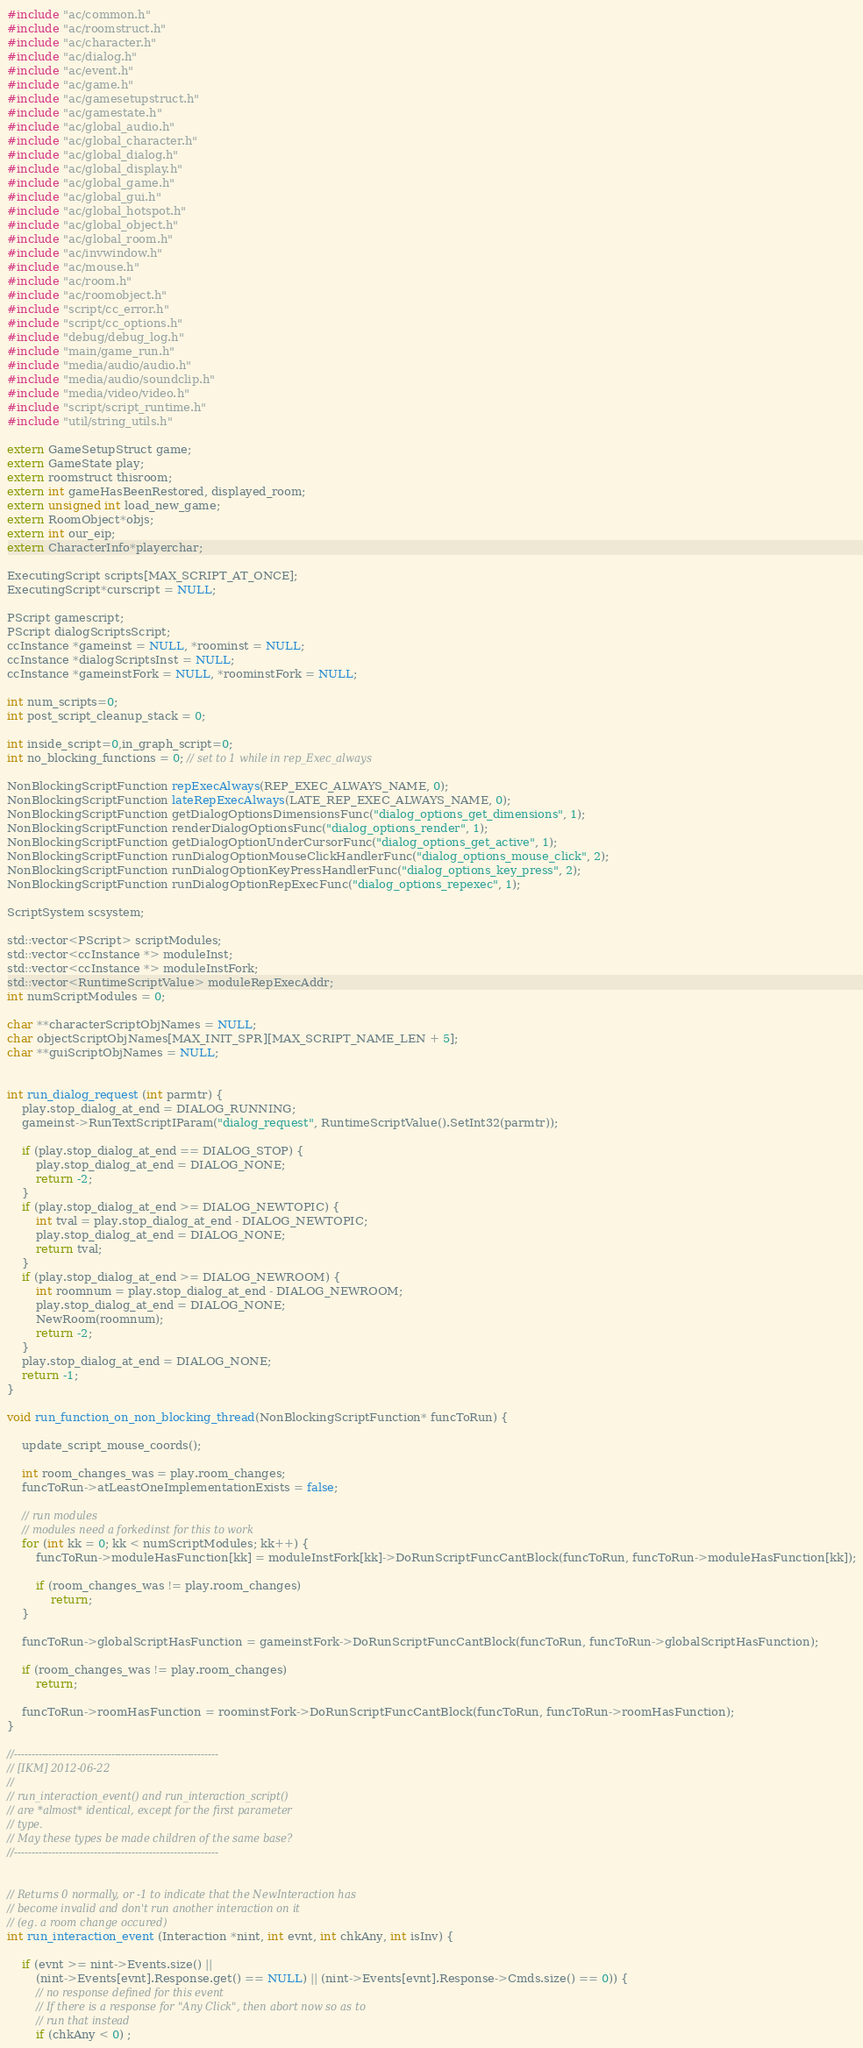Convert code to text. <code><loc_0><loc_0><loc_500><loc_500><_C++_>#include "ac/common.h"
#include "ac/roomstruct.h"
#include "ac/character.h"
#include "ac/dialog.h"
#include "ac/event.h"
#include "ac/game.h"
#include "ac/gamesetupstruct.h"
#include "ac/gamestate.h"
#include "ac/global_audio.h"
#include "ac/global_character.h"
#include "ac/global_dialog.h"
#include "ac/global_display.h"
#include "ac/global_game.h"
#include "ac/global_gui.h"
#include "ac/global_hotspot.h"
#include "ac/global_object.h"
#include "ac/global_room.h"
#include "ac/invwindow.h"
#include "ac/mouse.h"
#include "ac/room.h"
#include "ac/roomobject.h"
#include "script/cc_error.h"
#include "script/cc_options.h"
#include "debug/debug_log.h"
#include "main/game_run.h"
#include "media/audio/audio.h"
#include "media/audio/soundclip.h"
#include "media/video/video.h"
#include "script/script_runtime.h"
#include "util/string_utils.h"

extern GameSetupStruct game;
extern GameState play;
extern roomstruct thisroom;
extern int gameHasBeenRestored, displayed_room;
extern unsigned int load_new_game;
extern RoomObject*objs;
extern int our_eip;
extern CharacterInfo*playerchar;

ExecutingScript scripts[MAX_SCRIPT_AT_ONCE];
ExecutingScript*curscript = NULL;

PScript gamescript;
PScript dialogScriptsScript;
ccInstance *gameinst = NULL, *roominst = NULL;
ccInstance *dialogScriptsInst = NULL;
ccInstance *gameinstFork = NULL, *roominstFork = NULL;

int num_scripts=0;
int post_script_cleanup_stack = 0;

int inside_script=0,in_graph_script=0;
int no_blocking_functions = 0; // set to 1 while in rep_Exec_always

NonBlockingScriptFunction repExecAlways(REP_EXEC_ALWAYS_NAME, 0);
NonBlockingScriptFunction lateRepExecAlways(LATE_REP_EXEC_ALWAYS_NAME, 0);
NonBlockingScriptFunction getDialogOptionsDimensionsFunc("dialog_options_get_dimensions", 1);
NonBlockingScriptFunction renderDialogOptionsFunc("dialog_options_render", 1);
NonBlockingScriptFunction getDialogOptionUnderCursorFunc("dialog_options_get_active", 1);
NonBlockingScriptFunction runDialogOptionMouseClickHandlerFunc("dialog_options_mouse_click", 2);
NonBlockingScriptFunction runDialogOptionKeyPressHandlerFunc("dialog_options_key_press", 2);
NonBlockingScriptFunction runDialogOptionRepExecFunc("dialog_options_repexec", 1);

ScriptSystem scsystem;

std::vector<PScript> scriptModules;
std::vector<ccInstance *> moduleInst;
std::vector<ccInstance *> moduleInstFork;
std::vector<RuntimeScriptValue> moduleRepExecAddr;
int numScriptModules = 0;

char **characterScriptObjNames = NULL;
char objectScriptObjNames[MAX_INIT_SPR][MAX_SCRIPT_NAME_LEN + 5];
char **guiScriptObjNames = NULL;


int run_dialog_request (int parmtr) {
    play.stop_dialog_at_end = DIALOG_RUNNING;
    gameinst->RunTextScriptIParam("dialog_request", RuntimeScriptValue().SetInt32(parmtr));

    if (play.stop_dialog_at_end == DIALOG_STOP) {
        play.stop_dialog_at_end = DIALOG_NONE;
        return -2;
    }
    if (play.stop_dialog_at_end >= DIALOG_NEWTOPIC) {
        int tval = play.stop_dialog_at_end - DIALOG_NEWTOPIC;
        play.stop_dialog_at_end = DIALOG_NONE;
        return tval;
    }
    if (play.stop_dialog_at_end >= DIALOG_NEWROOM) {
        int roomnum = play.stop_dialog_at_end - DIALOG_NEWROOM;
        play.stop_dialog_at_end = DIALOG_NONE;
        NewRoom(roomnum);
        return -2;
    }
    play.stop_dialog_at_end = DIALOG_NONE;
    return -1;
}

void run_function_on_non_blocking_thread(NonBlockingScriptFunction* funcToRun) {

    update_script_mouse_coords();

    int room_changes_was = play.room_changes;
    funcToRun->atLeastOneImplementationExists = false;

    // run modules
    // modules need a forkedinst for this to work
    for (int kk = 0; kk < numScriptModules; kk++) {
        funcToRun->moduleHasFunction[kk] = moduleInstFork[kk]->DoRunScriptFuncCantBlock(funcToRun, funcToRun->moduleHasFunction[kk]);

        if (room_changes_was != play.room_changes)
            return;
    }

    funcToRun->globalScriptHasFunction = gameinstFork->DoRunScriptFuncCantBlock(funcToRun, funcToRun->globalScriptHasFunction);

    if (room_changes_was != play.room_changes)
        return;

    funcToRun->roomHasFunction = roominstFork->DoRunScriptFuncCantBlock(funcToRun, funcToRun->roomHasFunction);
}

//-----------------------------------------------------------
// [IKM] 2012-06-22
//
// run_interaction_event() and run_interaction_script()
// are *almost* identical, except for the first parameter
// type.
// May these types be made children of the same base?
//-----------------------------------------------------------


// Returns 0 normally, or -1 to indicate that the NewInteraction has
// become invalid and don't run another interaction on it
// (eg. a room change occured)
int run_interaction_event (Interaction *nint, int evnt, int chkAny, int isInv) {

    if (evnt >= nint->Events.size() ||
        (nint->Events[evnt].Response.get() == NULL) || (nint->Events[evnt].Response->Cmds.size() == 0)) {
        // no response defined for this event
        // If there is a response for "Any Click", then abort now so as to
        // run that instead
        if (chkAny < 0) ;</code> 